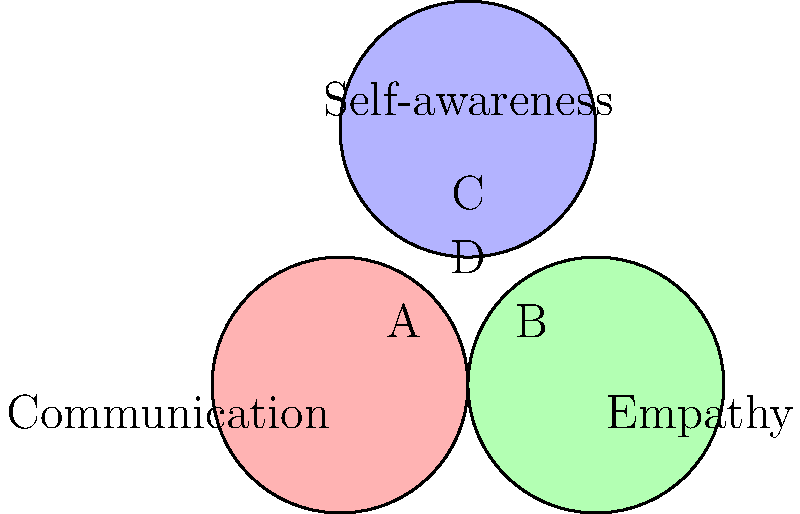In the Venn diagram above, three key areas of personal growth in a relationship are represented: Communication, Empathy, and Self-awareness. Which region (labeled A, B, C, or D) represents the intersection of all three areas, indicating a balanced approach to relationship growth? To answer this question, we need to analyze the Venn diagram and understand what each region represents:

1. The red circle represents Communication.
2. The green circle represents Empathy.
3. The blue circle represents Self-awareness.

Now, let's examine each labeled region:

A: This region is exclusively within the Communication circle, not overlapping with the others.
B: This region is exclusively within the Empathy circle, not overlapping with the others.
C: This region is exclusively within the Self-awareness circle, not overlapping with the others.
D: This region is at the center where all three circles overlap.

The question asks for the region that represents the intersection of all three areas. This would be the area where Communication, Empathy, and Self-awareness all overlap, indicating a balanced approach to relationship growth.

Therefore, the correct answer is region D, as it is the only area where all three circles intersect.
Answer: D 